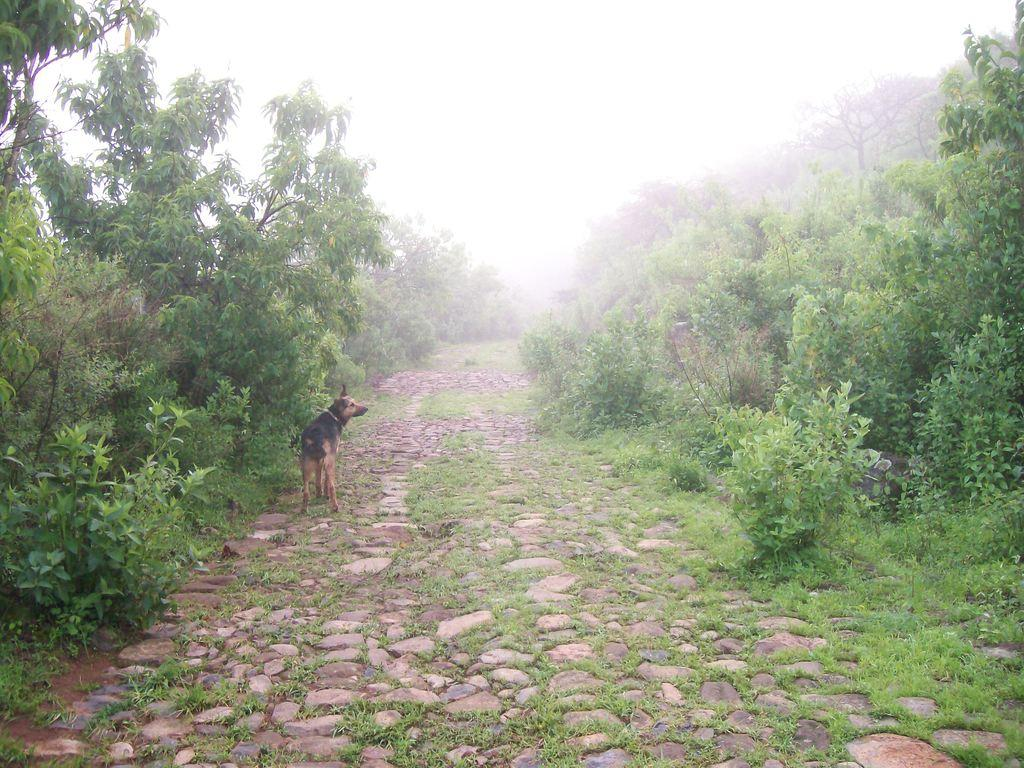What animal is present in the image? There is a dog in the image. What colors can be seen on the dog? The dog is black and brown in color. Where is the dog positioned in the image? The dog is standing in the middle of the image. What type of natural scenery is visible in the image? There are trees visible in the image. What is the condition of the sky in the image? The sky is clear in the image. How many coats is the dog wearing in the image? The dog is not wearing any coats in the image. What type of tub is visible in the image? There is no tub present in the image. 